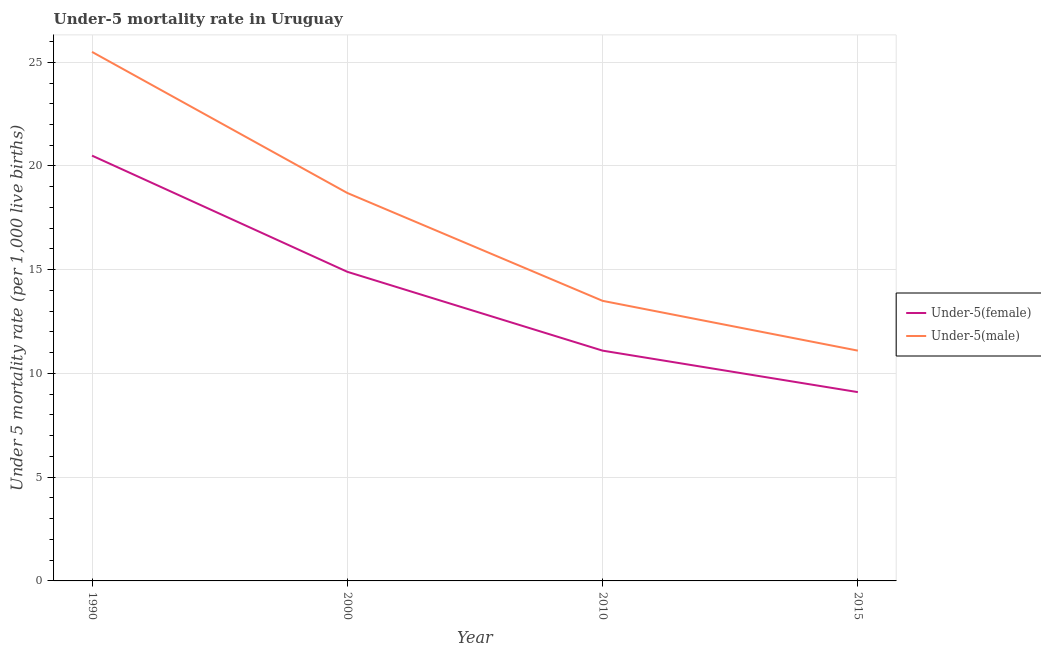Across all years, what is the maximum under-5 male mortality rate?
Keep it short and to the point. 25.5. Across all years, what is the minimum under-5 male mortality rate?
Your answer should be compact. 11.1. In which year was the under-5 male mortality rate maximum?
Offer a very short reply. 1990. In which year was the under-5 female mortality rate minimum?
Offer a very short reply. 2015. What is the total under-5 female mortality rate in the graph?
Ensure brevity in your answer.  55.6. What is the difference between the under-5 male mortality rate in 2000 and the under-5 female mortality rate in 1990?
Keep it short and to the point. -1.8. What is the average under-5 male mortality rate per year?
Provide a short and direct response. 17.2. In the year 2000, what is the difference between the under-5 female mortality rate and under-5 male mortality rate?
Your answer should be compact. -3.8. What is the ratio of the under-5 female mortality rate in 1990 to that in 2010?
Your response must be concise. 1.85. Is the under-5 female mortality rate in 1990 less than that in 2015?
Your response must be concise. No. What is the difference between the highest and the second highest under-5 male mortality rate?
Provide a succinct answer. 6.8. What is the difference between the highest and the lowest under-5 female mortality rate?
Ensure brevity in your answer.  11.4. In how many years, is the under-5 female mortality rate greater than the average under-5 female mortality rate taken over all years?
Offer a very short reply. 2. Is the under-5 male mortality rate strictly less than the under-5 female mortality rate over the years?
Offer a very short reply. No. How many years are there in the graph?
Give a very brief answer. 4. What is the difference between two consecutive major ticks on the Y-axis?
Offer a terse response. 5. Are the values on the major ticks of Y-axis written in scientific E-notation?
Keep it short and to the point. No. Does the graph contain grids?
Your answer should be very brief. Yes. Where does the legend appear in the graph?
Provide a short and direct response. Center right. How are the legend labels stacked?
Your response must be concise. Vertical. What is the title of the graph?
Give a very brief answer. Under-5 mortality rate in Uruguay. Does "Male entrants" appear as one of the legend labels in the graph?
Ensure brevity in your answer.  No. What is the label or title of the X-axis?
Your response must be concise. Year. What is the label or title of the Y-axis?
Provide a short and direct response. Under 5 mortality rate (per 1,0 live births). What is the Under 5 mortality rate (per 1,000 live births) in Under-5(female) in 1990?
Your response must be concise. 20.5. What is the Under 5 mortality rate (per 1,000 live births) of Under-5(female) in 2000?
Keep it short and to the point. 14.9. What is the Under 5 mortality rate (per 1,000 live births) of Under-5(male) in 2000?
Provide a short and direct response. 18.7. What is the Under 5 mortality rate (per 1,000 live births) of Under-5(male) in 2010?
Your answer should be very brief. 13.5. What is the Under 5 mortality rate (per 1,000 live births) of Under-5(female) in 2015?
Give a very brief answer. 9.1. What is the Under 5 mortality rate (per 1,000 live births) in Under-5(male) in 2015?
Provide a short and direct response. 11.1. Across all years, what is the maximum Under 5 mortality rate (per 1,000 live births) in Under-5(male)?
Keep it short and to the point. 25.5. What is the total Under 5 mortality rate (per 1,000 live births) of Under-5(female) in the graph?
Ensure brevity in your answer.  55.6. What is the total Under 5 mortality rate (per 1,000 live births) of Under-5(male) in the graph?
Give a very brief answer. 68.8. What is the difference between the Under 5 mortality rate (per 1,000 live births) in Under-5(female) in 1990 and that in 2000?
Make the answer very short. 5.6. What is the difference between the Under 5 mortality rate (per 1,000 live births) of Under-5(male) in 1990 and that in 2000?
Ensure brevity in your answer.  6.8. What is the difference between the Under 5 mortality rate (per 1,000 live births) in Under-5(male) in 1990 and that in 2015?
Ensure brevity in your answer.  14.4. What is the difference between the Under 5 mortality rate (per 1,000 live births) in Under-5(female) in 2000 and that in 2010?
Give a very brief answer. 3.8. What is the difference between the Under 5 mortality rate (per 1,000 live births) in Under-5(male) in 2000 and that in 2015?
Make the answer very short. 7.6. What is the difference between the Under 5 mortality rate (per 1,000 live births) in Under-5(female) in 1990 and the Under 5 mortality rate (per 1,000 live births) in Under-5(male) in 2010?
Ensure brevity in your answer.  7. What is the difference between the Under 5 mortality rate (per 1,000 live births) in Under-5(female) in 2010 and the Under 5 mortality rate (per 1,000 live births) in Under-5(male) in 2015?
Ensure brevity in your answer.  0. What is the average Under 5 mortality rate (per 1,000 live births) in Under-5(female) per year?
Provide a short and direct response. 13.9. In the year 1990, what is the difference between the Under 5 mortality rate (per 1,000 live births) of Under-5(female) and Under 5 mortality rate (per 1,000 live births) of Under-5(male)?
Ensure brevity in your answer.  -5. What is the ratio of the Under 5 mortality rate (per 1,000 live births) of Under-5(female) in 1990 to that in 2000?
Offer a very short reply. 1.38. What is the ratio of the Under 5 mortality rate (per 1,000 live births) of Under-5(male) in 1990 to that in 2000?
Provide a short and direct response. 1.36. What is the ratio of the Under 5 mortality rate (per 1,000 live births) in Under-5(female) in 1990 to that in 2010?
Your answer should be very brief. 1.85. What is the ratio of the Under 5 mortality rate (per 1,000 live births) of Under-5(male) in 1990 to that in 2010?
Offer a terse response. 1.89. What is the ratio of the Under 5 mortality rate (per 1,000 live births) of Under-5(female) in 1990 to that in 2015?
Your answer should be compact. 2.25. What is the ratio of the Under 5 mortality rate (per 1,000 live births) of Under-5(male) in 1990 to that in 2015?
Ensure brevity in your answer.  2.3. What is the ratio of the Under 5 mortality rate (per 1,000 live births) of Under-5(female) in 2000 to that in 2010?
Your answer should be compact. 1.34. What is the ratio of the Under 5 mortality rate (per 1,000 live births) of Under-5(male) in 2000 to that in 2010?
Make the answer very short. 1.39. What is the ratio of the Under 5 mortality rate (per 1,000 live births) of Under-5(female) in 2000 to that in 2015?
Your answer should be compact. 1.64. What is the ratio of the Under 5 mortality rate (per 1,000 live births) in Under-5(male) in 2000 to that in 2015?
Keep it short and to the point. 1.68. What is the ratio of the Under 5 mortality rate (per 1,000 live births) in Under-5(female) in 2010 to that in 2015?
Make the answer very short. 1.22. What is the ratio of the Under 5 mortality rate (per 1,000 live births) of Under-5(male) in 2010 to that in 2015?
Provide a short and direct response. 1.22. What is the difference between the highest and the second highest Under 5 mortality rate (per 1,000 live births) in Under-5(female)?
Your answer should be compact. 5.6. What is the difference between the highest and the second highest Under 5 mortality rate (per 1,000 live births) in Under-5(male)?
Make the answer very short. 6.8. 